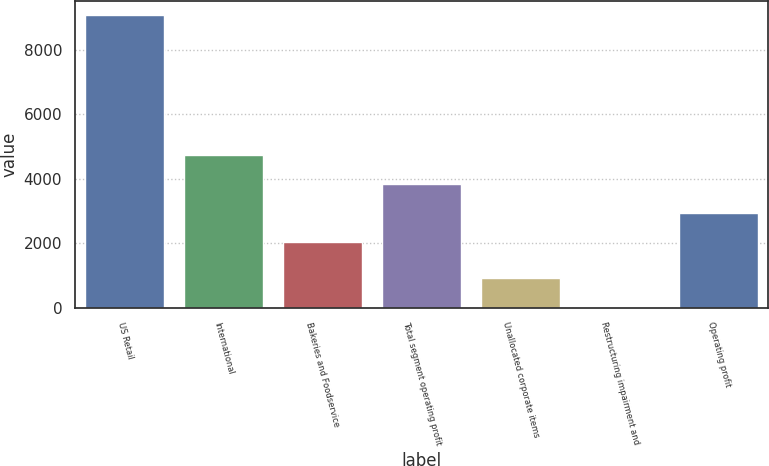Convert chart. <chart><loc_0><loc_0><loc_500><loc_500><bar_chart><fcel>US Retail<fcel>International<fcel>Bakeries and Foodservice<fcel>Total segment operating profit<fcel>Unallocated corporate items<fcel>Restructuring impairment and<fcel>Operating profit<nl><fcel>9072<fcel>4736.6<fcel>2021.3<fcel>3831.5<fcel>926.1<fcel>21<fcel>2926.4<nl></chart> 